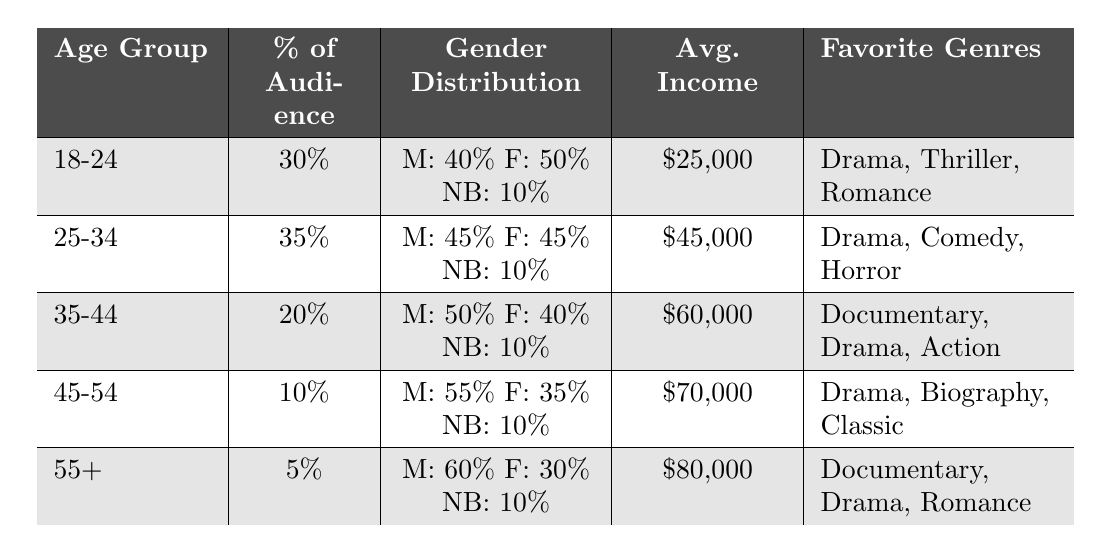What is the age group that represents the largest percentage of the audience? The table shows the percentage of the audience for each age group. The age group "25-34" has the highest percentage at 35%.
Answer: 25-34 Which age group has the lowest average income? The average income is listed for each age group. The "18-24" age group has the lowest income at $25,000.
Answer: 18-24 What percentage of the audience is aged 45-54? The table indicates that the "45-54" age group comprises 10% of the total audience.
Answer: 10% Is the favorite genre for the age group 35-44 "Horror"? According to the table, the favorite genres for the "35-44" age group are listed as Documentary, Drama, and Action. "Horror" is not mentioned.
Answer: No What is the average income of the 55+ age group? The table specifies the average income for each age group, and the "55+" age group earns $80,000.
Answer: $80,000 Which age group has the most balanced gender distribution? The "25-34" age group has a gender distribution of 45% male and 45% female, with 10% non-binary, indicating a balanced distribution among these genders.
Answer: 25-34 What is the total percentage of the audience aged 35 and older? Summing the percentages for the age groups 35-44 (20%), 45-54 (10%), and 55+ (5%) gives 20% + 10% + 5% = 35%.
Answer: 35% What favorite genres do the "18-24" age group enjoy? The table lists the favorite genres for the "18-24" age group as Drama, Thriller, and Romance.
Answer: Drama, Thriller, Romance What is the gender distribution for the "45-54" age group? For the "45-54" age group, the gender distribution is 55% male, 35% female, and 10% non-binary.
Answer: M: 55%, F: 35%, NB: 10% Which age group has a favorite genre that includes "Biography"? The "45-54" age group includes "Biography" as one of its favorite genres, according to the table.
Answer: 45-54 